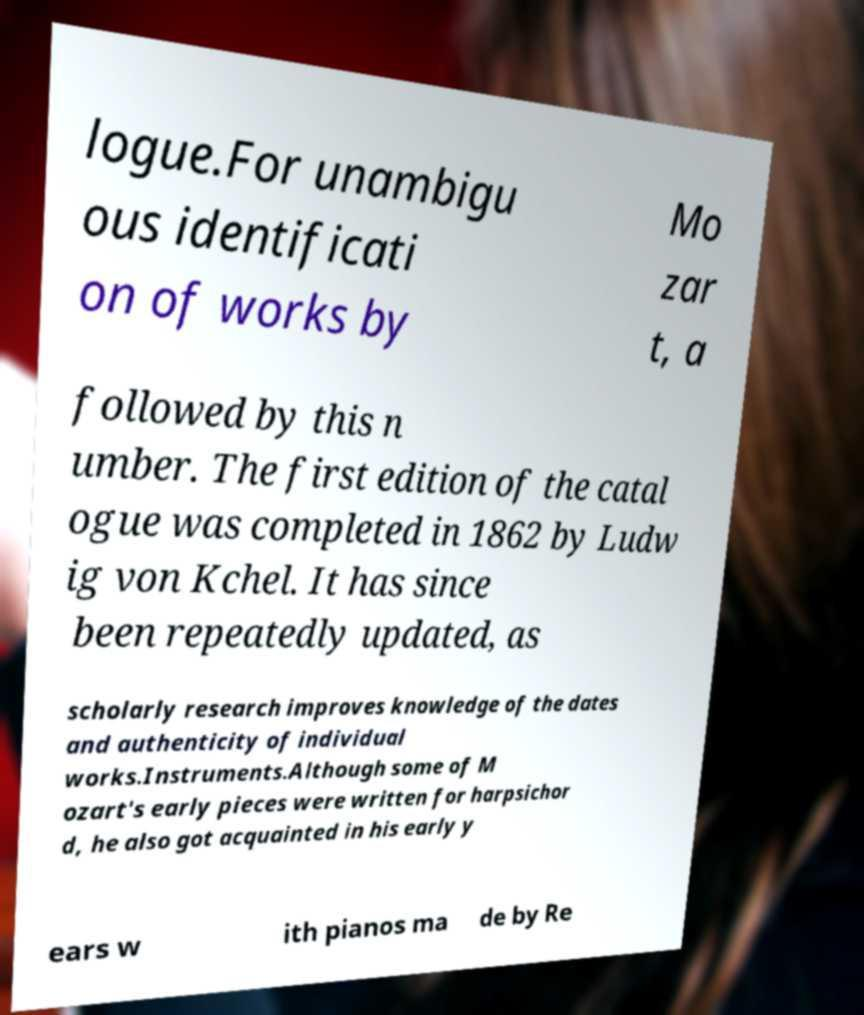There's text embedded in this image that I need extracted. Can you transcribe it verbatim? logue.For unambigu ous identificati on of works by Mo zar t, a followed by this n umber. The first edition of the catal ogue was completed in 1862 by Ludw ig von Kchel. It has since been repeatedly updated, as scholarly research improves knowledge of the dates and authenticity of individual works.Instruments.Although some of M ozart's early pieces were written for harpsichor d, he also got acquainted in his early y ears w ith pianos ma de by Re 